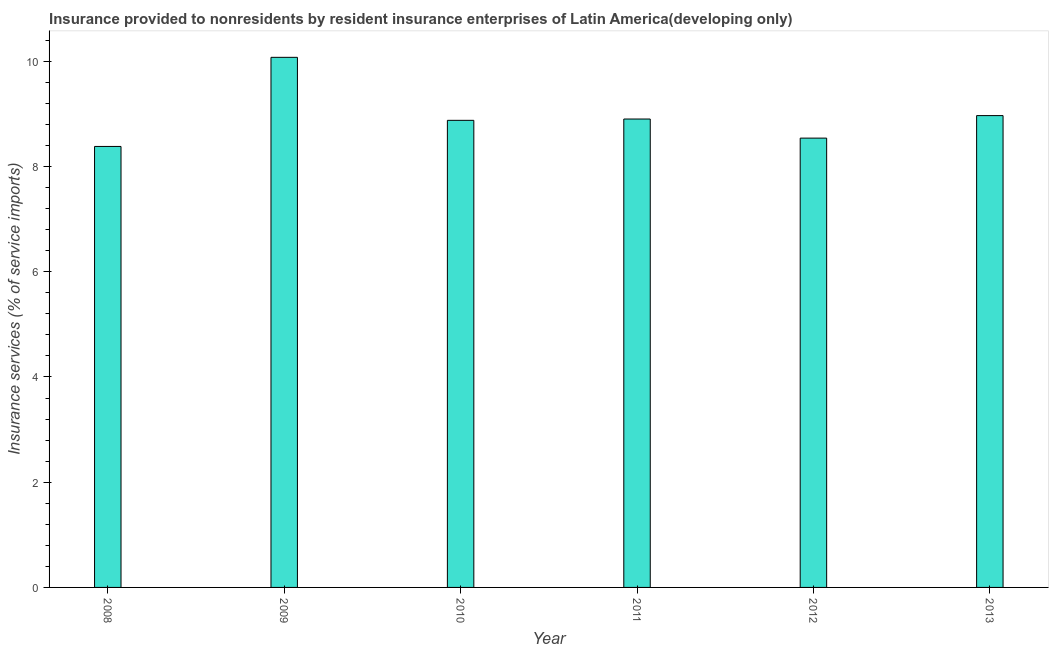Does the graph contain any zero values?
Make the answer very short. No. Does the graph contain grids?
Your answer should be compact. No. What is the title of the graph?
Provide a succinct answer. Insurance provided to nonresidents by resident insurance enterprises of Latin America(developing only). What is the label or title of the Y-axis?
Provide a short and direct response. Insurance services (% of service imports). What is the insurance and financial services in 2011?
Keep it short and to the point. 8.9. Across all years, what is the maximum insurance and financial services?
Your response must be concise. 10.08. Across all years, what is the minimum insurance and financial services?
Ensure brevity in your answer.  8.38. In which year was the insurance and financial services maximum?
Offer a very short reply. 2009. In which year was the insurance and financial services minimum?
Offer a very short reply. 2008. What is the sum of the insurance and financial services?
Give a very brief answer. 53.75. What is the difference between the insurance and financial services in 2012 and 2013?
Provide a succinct answer. -0.43. What is the average insurance and financial services per year?
Keep it short and to the point. 8.96. What is the median insurance and financial services?
Your answer should be very brief. 8.89. In how many years, is the insurance and financial services greater than 9.6 %?
Your response must be concise. 1. Do a majority of the years between 2009 and 2013 (inclusive) have insurance and financial services greater than 6 %?
Offer a terse response. Yes. What is the ratio of the insurance and financial services in 2008 to that in 2010?
Provide a short and direct response. 0.94. Is the insurance and financial services in 2009 less than that in 2011?
Provide a succinct answer. No. What is the difference between the highest and the second highest insurance and financial services?
Make the answer very short. 1.11. What is the difference between the highest and the lowest insurance and financial services?
Offer a very short reply. 1.69. In how many years, is the insurance and financial services greater than the average insurance and financial services taken over all years?
Provide a short and direct response. 2. How many bars are there?
Ensure brevity in your answer.  6. Are all the bars in the graph horizontal?
Keep it short and to the point. No. How many years are there in the graph?
Make the answer very short. 6. What is the Insurance services (% of service imports) of 2008?
Give a very brief answer. 8.38. What is the Insurance services (% of service imports) of 2009?
Give a very brief answer. 10.08. What is the Insurance services (% of service imports) of 2010?
Your answer should be very brief. 8.88. What is the Insurance services (% of service imports) of 2011?
Offer a very short reply. 8.9. What is the Insurance services (% of service imports) of 2012?
Your answer should be very brief. 8.54. What is the Insurance services (% of service imports) in 2013?
Offer a very short reply. 8.97. What is the difference between the Insurance services (% of service imports) in 2008 and 2009?
Your answer should be compact. -1.69. What is the difference between the Insurance services (% of service imports) in 2008 and 2010?
Ensure brevity in your answer.  -0.5. What is the difference between the Insurance services (% of service imports) in 2008 and 2011?
Offer a terse response. -0.52. What is the difference between the Insurance services (% of service imports) in 2008 and 2012?
Keep it short and to the point. -0.16. What is the difference between the Insurance services (% of service imports) in 2008 and 2013?
Give a very brief answer. -0.59. What is the difference between the Insurance services (% of service imports) in 2009 and 2010?
Give a very brief answer. 1.2. What is the difference between the Insurance services (% of service imports) in 2009 and 2011?
Your response must be concise. 1.17. What is the difference between the Insurance services (% of service imports) in 2009 and 2012?
Provide a short and direct response. 1.54. What is the difference between the Insurance services (% of service imports) in 2009 and 2013?
Offer a very short reply. 1.11. What is the difference between the Insurance services (% of service imports) in 2010 and 2011?
Provide a short and direct response. -0.02. What is the difference between the Insurance services (% of service imports) in 2010 and 2012?
Offer a very short reply. 0.34. What is the difference between the Insurance services (% of service imports) in 2010 and 2013?
Your answer should be compact. -0.09. What is the difference between the Insurance services (% of service imports) in 2011 and 2012?
Ensure brevity in your answer.  0.36. What is the difference between the Insurance services (% of service imports) in 2011 and 2013?
Offer a very short reply. -0.06. What is the difference between the Insurance services (% of service imports) in 2012 and 2013?
Your answer should be very brief. -0.43. What is the ratio of the Insurance services (% of service imports) in 2008 to that in 2009?
Your answer should be very brief. 0.83. What is the ratio of the Insurance services (% of service imports) in 2008 to that in 2010?
Keep it short and to the point. 0.94. What is the ratio of the Insurance services (% of service imports) in 2008 to that in 2011?
Provide a succinct answer. 0.94. What is the ratio of the Insurance services (% of service imports) in 2008 to that in 2012?
Your answer should be very brief. 0.98. What is the ratio of the Insurance services (% of service imports) in 2008 to that in 2013?
Ensure brevity in your answer.  0.94. What is the ratio of the Insurance services (% of service imports) in 2009 to that in 2010?
Offer a very short reply. 1.14. What is the ratio of the Insurance services (% of service imports) in 2009 to that in 2011?
Provide a short and direct response. 1.13. What is the ratio of the Insurance services (% of service imports) in 2009 to that in 2012?
Keep it short and to the point. 1.18. What is the ratio of the Insurance services (% of service imports) in 2009 to that in 2013?
Keep it short and to the point. 1.12. What is the ratio of the Insurance services (% of service imports) in 2010 to that in 2011?
Provide a short and direct response. 1. What is the ratio of the Insurance services (% of service imports) in 2010 to that in 2012?
Make the answer very short. 1.04. What is the ratio of the Insurance services (% of service imports) in 2010 to that in 2013?
Your answer should be very brief. 0.99. What is the ratio of the Insurance services (% of service imports) in 2011 to that in 2012?
Offer a very short reply. 1.04. 